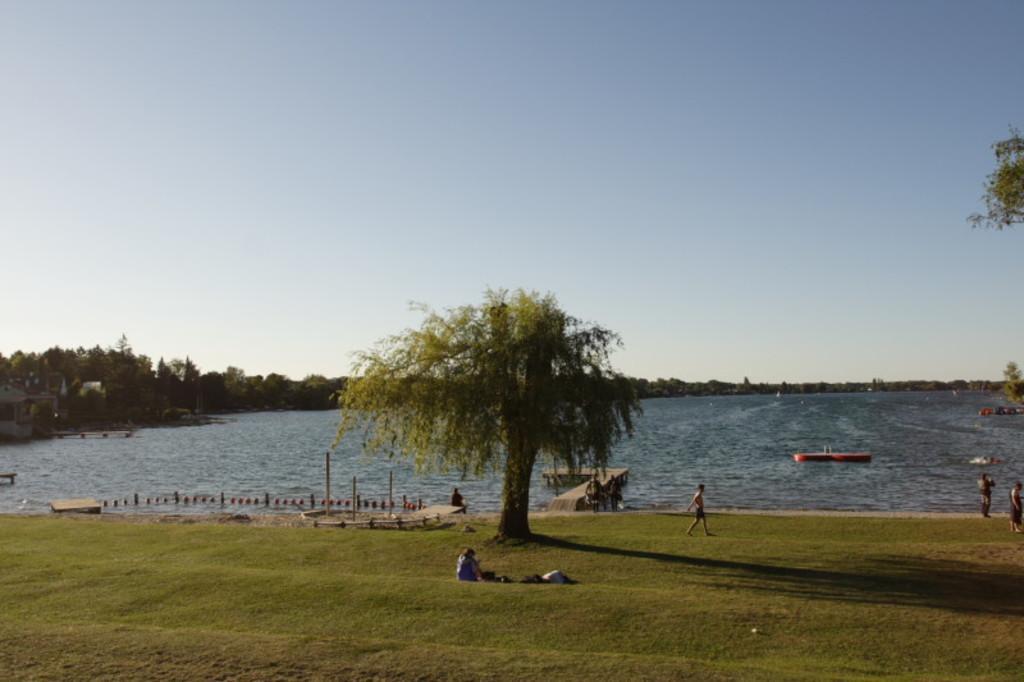Could you give a brief overview of what you see in this image? In the image there is a grass surface in the foreground, on the grass surface there are few people and trees. Behind the grass surface there is a water surface and in the background there are many trees. 